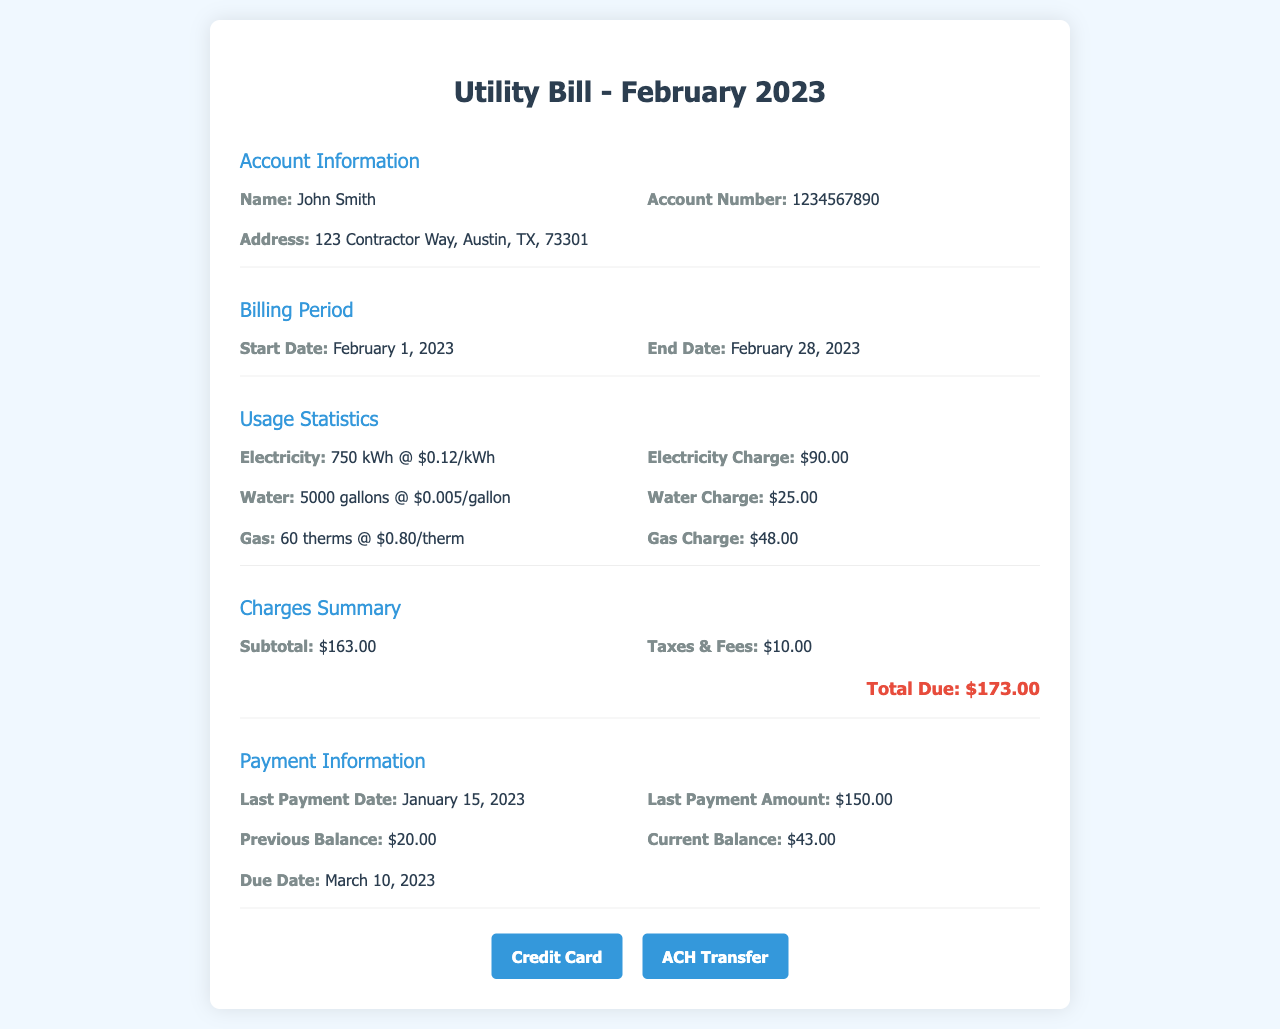What is the account number? The account number is a specific identifier for the utility account listed in the document.
Answer: 1234567890 What is the total due amount? The total due amount is found in the Charges Summary section, which includes all charges and fees.
Answer: $173.00 How much was the last payment amount? The last payment amount is specified in the Payment Information section.
Answer: $150.00 When is the due date for the payment? The due date can be found in the Payment Information section, indicating when the payment must be made.
Answer: March 10, 2023 What was the electricity usage in kWh? The electricity usage is detailed in the Usage Statistics section, showing how much electricity was consumed.
Answer: 750 kWh How much is the water charge? The water charge is listed under Usage Statistics, indicating the cost associated with water usage.
Answer: $25.00 What is the start date of the billing period? The start date of the billing period specifies when charges begin, found in the Billing Period section.
Answer: February 1, 2023 What is the previous balance? The previous balance reflects any outstanding amount from the last billing cycle and is found in the Payment Information section.
Answer: $20.00 How many therms of gas were used? The gas usage is indicated in the Usage Statistics section, showing the quantity consumed during the billing period.
Answer: 60 therms 